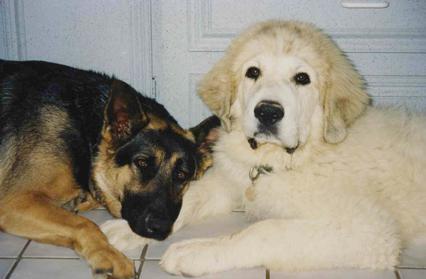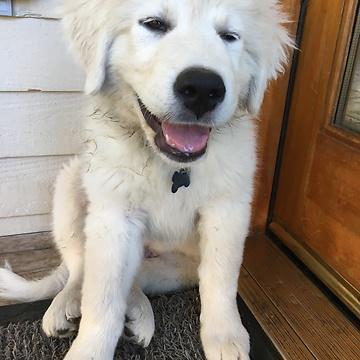The first image is the image on the left, the second image is the image on the right. Examine the images to the left and right. Is the description "One dog is sitting." accurate? Answer yes or no. Yes. The first image is the image on the left, the second image is the image on the right. For the images shown, is this caption "there are two dogs in the image pair" true? Answer yes or no. No. 